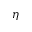<formula> <loc_0><loc_0><loc_500><loc_500>\eta</formula> 